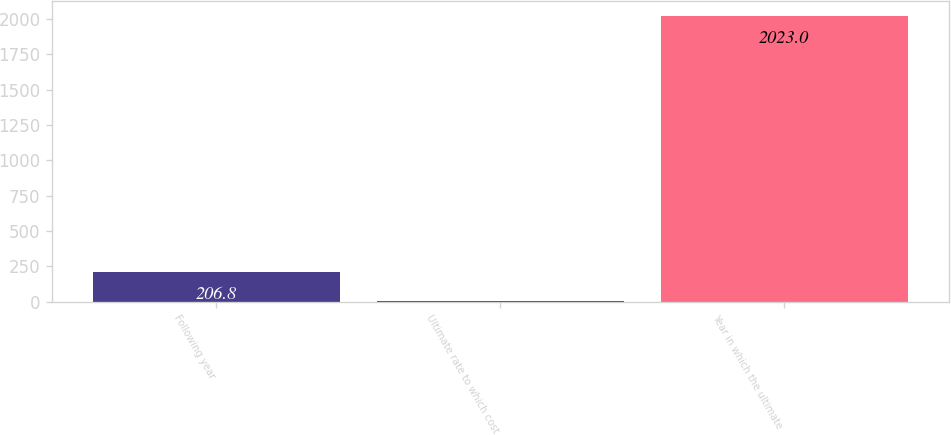Convert chart to OTSL. <chart><loc_0><loc_0><loc_500><loc_500><bar_chart><fcel>Following year<fcel>Ultimate rate to which cost<fcel>Year in which the ultimate<nl><fcel>206.8<fcel>5<fcel>2023<nl></chart> 